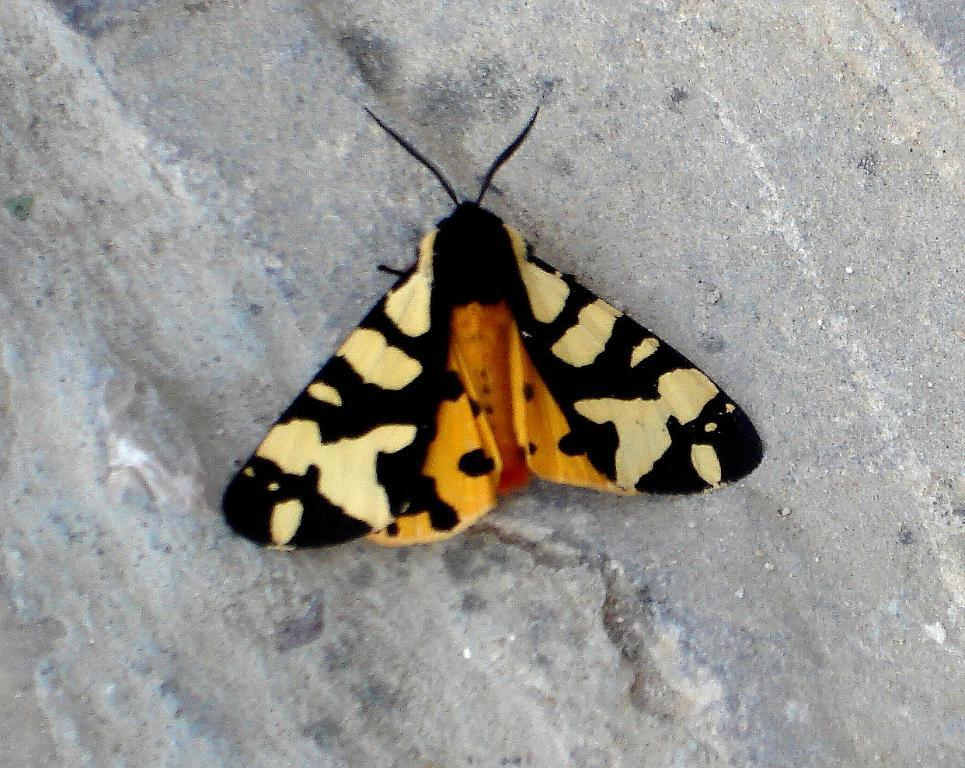What is the main subject of the image? The main subject of the image is a butterfly representation. What type of bulb is connected to the cord in the image? There is no bulb or cord present in the image; it only features a butterfly representation. 